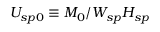Convert formula to latex. <formula><loc_0><loc_0><loc_500><loc_500>U _ { s p 0 } \equiv M _ { 0 } / W _ { s p } H _ { s p }</formula> 